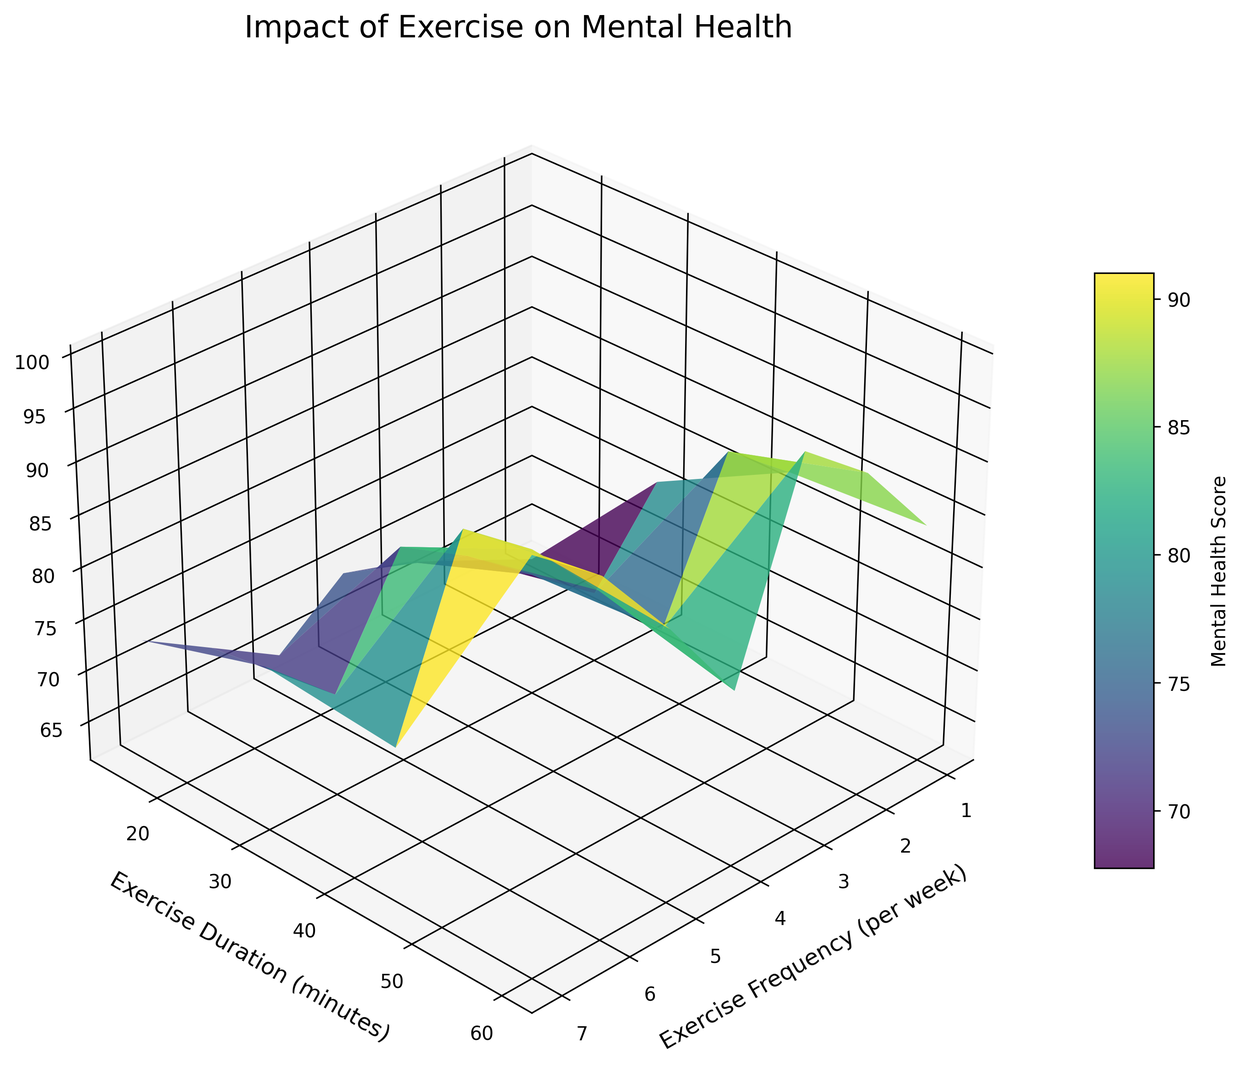What's the highest Mental Health Score on the graph? The highest Mental Health Score can be found by identifying the tallest peak on the surface plot. From the data, the highest score is 100, which occurs at an exercise frequency of 7 times per week with a duration of 60 minutes.
Answer: 100 At an exercise frequency of 5 times per week, how does the Mental Health Score change with increasing duration? Look at the line corresponding to 5 times per week. Starting from 15 minutes with a score of 74, it increases to 30 minutes with a score of 81, 45 minutes with a score of 88, and 60 minutes with a score of 93. The Mental Health Score steadily increases with longer exercise durations.
Answer: The score increases steadily Is there a point where increasing the duration no longer significantly improves the Mental Health Score at a given frequency? Analyze the slope of the surface plot for each frequency band. Generally, each increase in duration leads to a noticeable improvement in Mental Health Score, indicating no sharp plateau within the given data.
Answer: No Which has a greater effect on Mental Health Score: increasing exercise frequency or increasing exercise duration? Compare the changes in Mental Health Score across the axes of exercise frequency and duration. Both frequency and duration positively impact the score, but higher frequencies with moderate durations show significant increases, indicating frequency might have a slightly higher impact.
Answer: Exercise frequency (slightly) If someone exercises twice a week for 45 minutes each session, what is their approximate Mental Health Score? Locate the point corresponding to 2 times per week and 45 minutes duration. The surface plot indicates a Mental Health Score of around 73.
Answer: 73 Which exercise frequency and duration combination shows the highest improvement in Mental Health Score from the minimum exercise frequency? The minimum exercise frequency is 1 time per week. The highest score at this frequency is with a 60-minute duration at a score of 70.
Answer: 60 mins at once per week What is the lowest Mental Health Score observed on the plot? The lowest Mental Health Score can be found at the minimum point of the surface plot. From the data, the lowest score is 62, which occurs at an exercise frequency of 1 time per week with a duration of 15 minutes.
Answer: 62 How does the Mental Health Score at an exercise frequency of 3 times per week and 30 minutes compare with 6 times per week and 30 minutes? Look at the points on the surface plot for these combinations. The score at 3 times per week with 30 minutes is 73, and the score at 6 times per week with 30 minutes is 84. The score is higher for the greater frequency.
Answer: Higher for 6/week What is the mental health score for exercising 4 times per week for 60 minutes, and how does it compare to exercising 7 times per week for 60 minutes? Locate the points on the surface plot: 4 times per week and 60 minutes corresponds to a score of 88, while 7 times per week and 60 minutes corresponds to a score of 100. The latter is significantly higher.
Answer: 88 vs. 100 Considering durations up to 45 minutes, which combination yields the maximum Mental Health Score? Analyze the plot for durations up to and including 45 minutes. Exercise frequencies of 7 times per week and 45 minutes yield the highest score of 95 among these conditions.
Answer: 7/week, 45 mins 